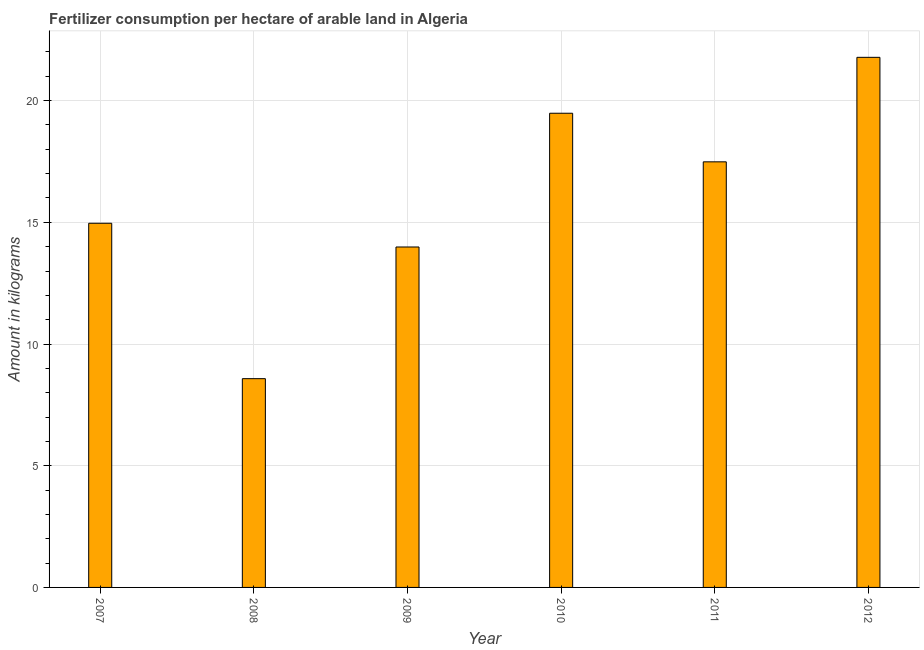What is the title of the graph?
Offer a terse response. Fertilizer consumption per hectare of arable land in Algeria . What is the label or title of the X-axis?
Make the answer very short. Year. What is the label or title of the Y-axis?
Keep it short and to the point. Amount in kilograms. What is the amount of fertilizer consumption in 2008?
Offer a very short reply. 8.58. Across all years, what is the maximum amount of fertilizer consumption?
Offer a terse response. 21.78. Across all years, what is the minimum amount of fertilizer consumption?
Make the answer very short. 8.58. In which year was the amount of fertilizer consumption maximum?
Make the answer very short. 2012. What is the sum of the amount of fertilizer consumption?
Your answer should be very brief. 96.27. What is the difference between the amount of fertilizer consumption in 2009 and 2011?
Your answer should be compact. -3.5. What is the average amount of fertilizer consumption per year?
Your answer should be compact. 16.05. What is the median amount of fertilizer consumption?
Provide a succinct answer. 16.22. In how many years, is the amount of fertilizer consumption greater than 14 kg?
Your answer should be compact. 4. What is the ratio of the amount of fertilizer consumption in 2008 to that in 2010?
Offer a terse response. 0.44. What is the difference between the highest and the second highest amount of fertilizer consumption?
Offer a terse response. 2.3. In how many years, is the amount of fertilizer consumption greater than the average amount of fertilizer consumption taken over all years?
Your answer should be very brief. 3. How many bars are there?
Provide a short and direct response. 6. Are all the bars in the graph horizontal?
Give a very brief answer. No. Are the values on the major ticks of Y-axis written in scientific E-notation?
Provide a succinct answer. No. What is the Amount in kilograms of 2007?
Your response must be concise. 14.96. What is the Amount in kilograms in 2008?
Keep it short and to the point. 8.58. What is the Amount in kilograms in 2009?
Keep it short and to the point. 13.99. What is the Amount in kilograms of 2010?
Your answer should be compact. 19.48. What is the Amount in kilograms of 2011?
Make the answer very short. 17.49. What is the Amount in kilograms in 2012?
Your answer should be compact. 21.78. What is the difference between the Amount in kilograms in 2007 and 2008?
Provide a short and direct response. 6.38. What is the difference between the Amount in kilograms in 2007 and 2009?
Offer a terse response. 0.97. What is the difference between the Amount in kilograms in 2007 and 2010?
Your answer should be compact. -4.52. What is the difference between the Amount in kilograms in 2007 and 2011?
Keep it short and to the point. -2.52. What is the difference between the Amount in kilograms in 2007 and 2012?
Offer a terse response. -6.82. What is the difference between the Amount in kilograms in 2008 and 2009?
Your answer should be compact. -5.41. What is the difference between the Amount in kilograms in 2008 and 2010?
Your answer should be compact. -10.9. What is the difference between the Amount in kilograms in 2008 and 2011?
Your answer should be compact. -8.91. What is the difference between the Amount in kilograms in 2008 and 2012?
Keep it short and to the point. -13.2. What is the difference between the Amount in kilograms in 2009 and 2010?
Offer a terse response. -5.49. What is the difference between the Amount in kilograms in 2009 and 2011?
Offer a very short reply. -3.5. What is the difference between the Amount in kilograms in 2009 and 2012?
Provide a succinct answer. -7.79. What is the difference between the Amount in kilograms in 2010 and 2011?
Offer a terse response. 2. What is the difference between the Amount in kilograms in 2010 and 2012?
Provide a short and direct response. -2.3. What is the difference between the Amount in kilograms in 2011 and 2012?
Give a very brief answer. -4.29. What is the ratio of the Amount in kilograms in 2007 to that in 2008?
Provide a short and direct response. 1.74. What is the ratio of the Amount in kilograms in 2007 to that in 2009?
Provide a succinct answer. 1.07. What is the ratio of the Amount in kilograms in 2007 to that in 2010?
Keep it short and to the point. 0.77. What is the ratio of the Amount in kilograms in 2007 to that in 2011?
Your answer should be compact. 0.86. What is the ratio of the Amount in kilograms in 2007 to that in 2012?
Provide a short and direct response. 0.69. What is the ratio of the Amount in kilograms in 2008 to that in 2009?
Ensure brevity in your answer.  0.61. What is the ratio of the Amount in kilograms in 2008 to that in 2010?
Give a very brief answer. 0.44. What is the ratio of the Amount in kilograms in 2008 to that in 2011?
Make the answer very short. 0.49. What is the ratio of the Amount in kilograms in 2008 to that in 2012?
Provide a succinct answer. 0.39. What is the ratio of the Amount in kilograms in 2009 to that in 2010?
Ensure brevity in your answer.  0.72. What is the ratio of the Amount in kilograms in 2009 to that in 2012?
Ensure brevity in your answer.  0.64. What is the ratio of the Amount in kilograms in 2010 to that in 2011?
Make the answer very short. 1.11. What is the ratio of the Amount in kilograms in 2010 to that in 2012?
Make the answer very short. 0.9. What is the ratio of the Amount in kilograms in 2011 to that in 2012?
Ensure brevity in your answer.  0.8. 